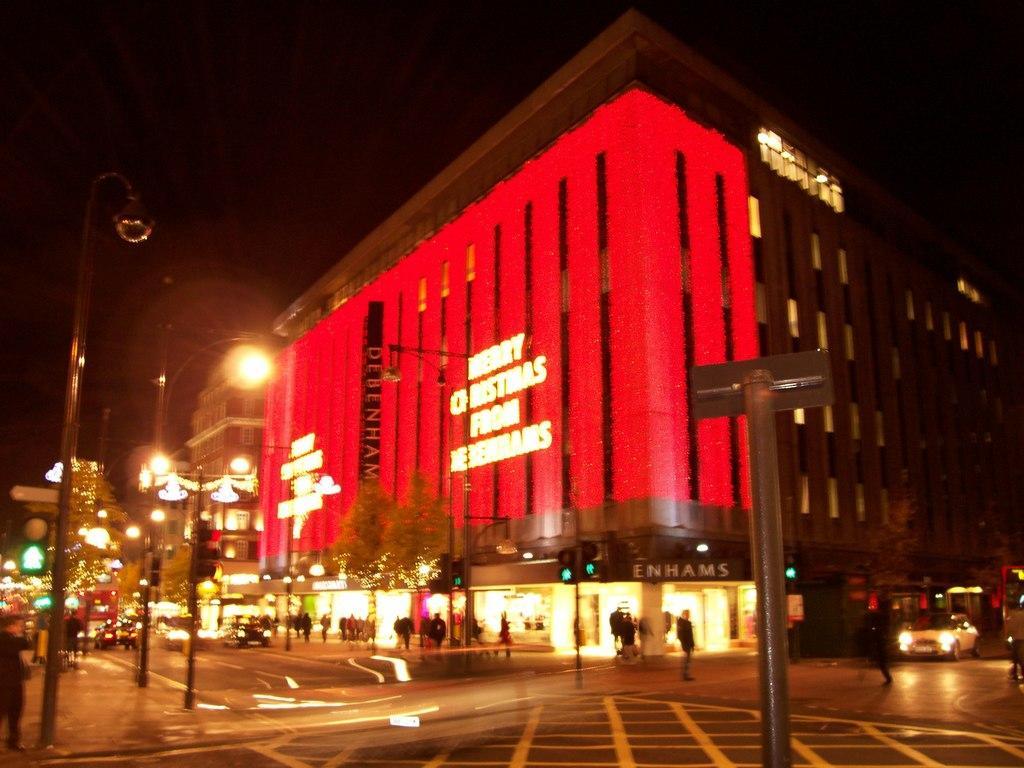Could you give a brief overview of what you see in this image? In this picture, we can see some vehicles on the road and groups of people walking on the path and on the left side of the people there are poles with lights and signals and on the right side of the people there is a tree and buildings. 